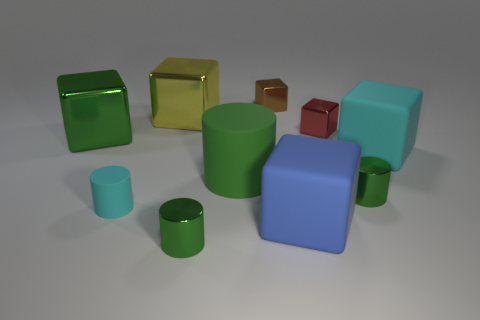Subtract all gray cubes. How many green cylinders are left? 3 Subtract 1 cylinders. How many cylinders are left? 3 Subtract all red cubes. How many cubes are left? 5 Subtract all cyan cylinders. How many cylinders are left? 3 Subtract all purple blocks. Subtract all cyan cylinders. How many blocks are left? 6 Subtract all cylinders. How many objects are left? 6 Add 4 small matte objects. How many small matte objects exist? 5 Subtract 0 purple cylinders. How many objects are left? 10 Subtract all green shiny cylinders. Subtract all blue blocks. How many objects are left? 7 Add 5 tiny cyan matte cylinders. How many tiny cyan matte cylinders are left? 6 